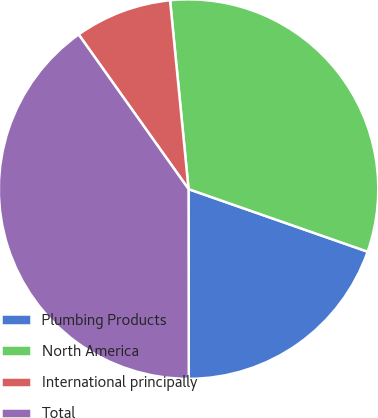Convert chart to OTSL. <chart><loc_0><loc_0><loc_500><loc_500><pie_chart><fcel>Plumbing Products<fcel>North America<fcel>International principally<fcel>Total<nl><fcel>19.63%<fcel>31.9%<fcel>8.28%<fcel>40.18%<nl></chart> 